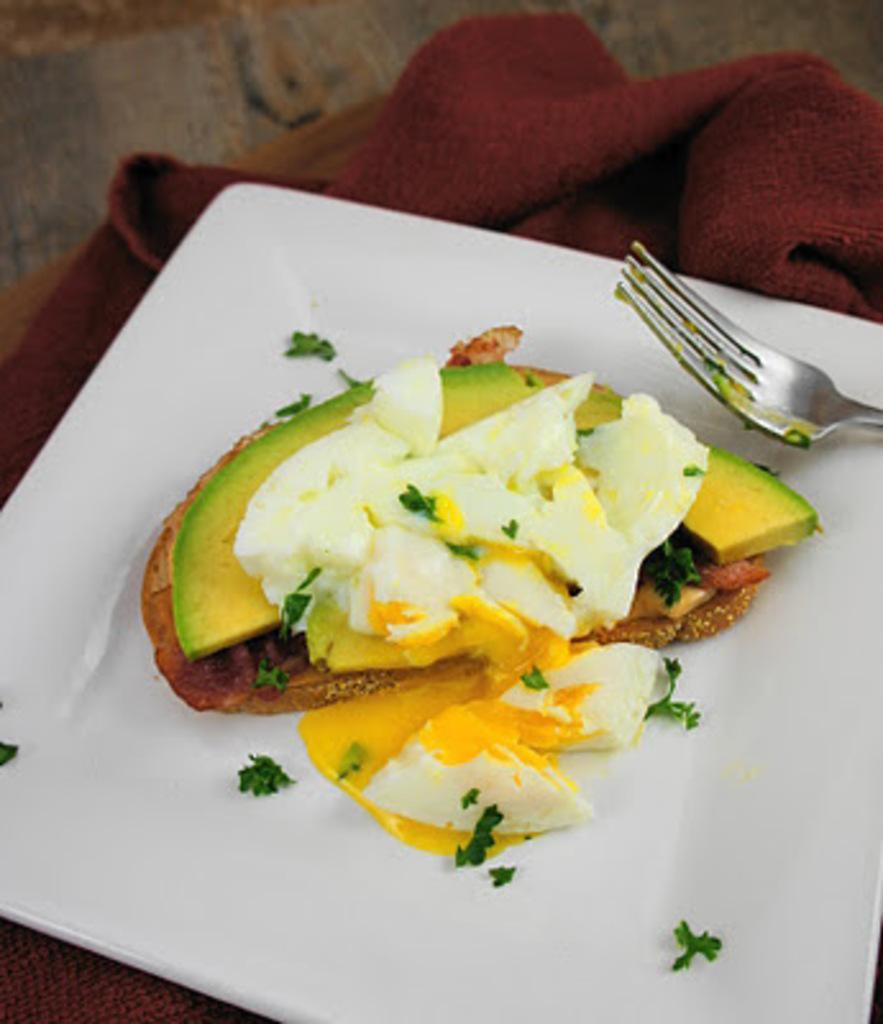Describe this image in one or two sentences. In this image we can see food and spoon in a plate placed on the cloth. 